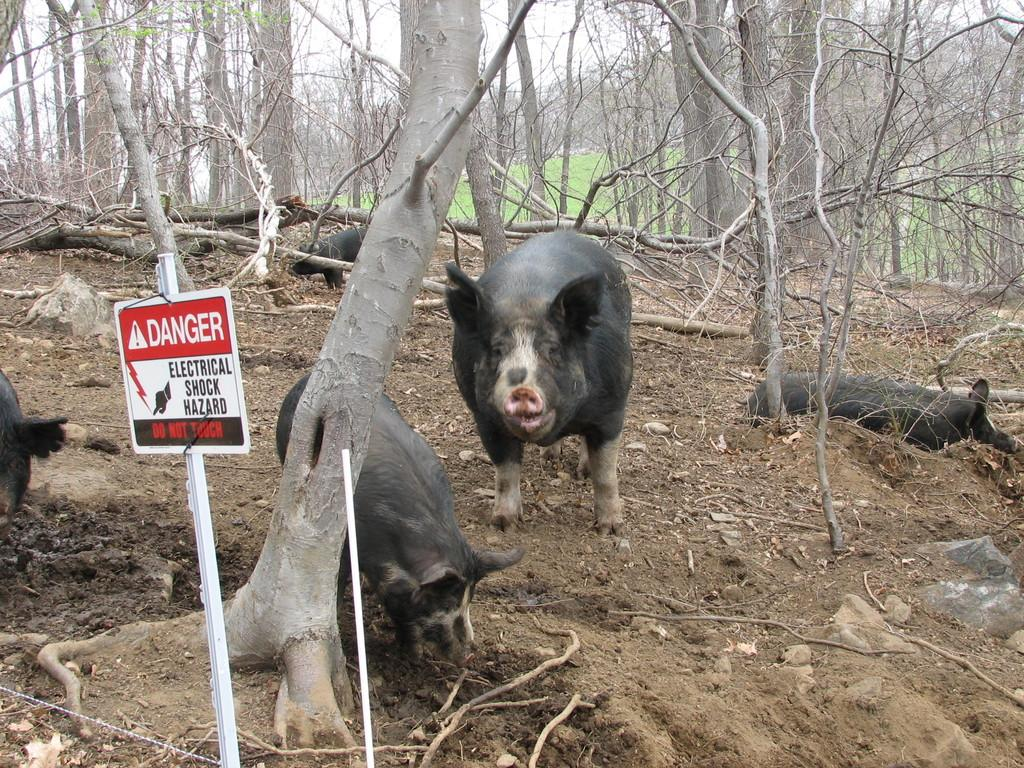What type of vegetation can be seen in the background of the image? There is grass in the background of the image. What else can be seen in the background of the image? There are tree trunks in the background of the image. What animals are present in the image? There are pigs in the image. What is located on the left side of the image? There is a caution board and a pole on the left side of the image. What type of comb is the boy using to groom the pigs in the image? There is no boy present in the image, and therefore no comb or grooming activity can be observed. 